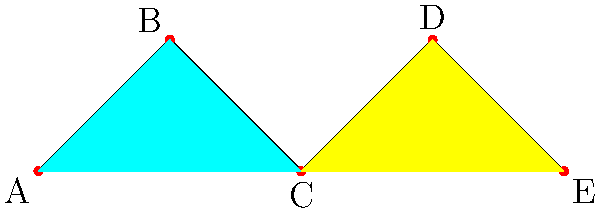Santander International is planning to optimize its ATM distribution in a city. The city can be represented as a graph where vertices are neighborhoods and edges indicate adjacent neighborhoods. ATMs in adjacent neighborhoods should have different maintenance schedules to ensure continuous service. Given the graph above, what is the minimum number of different maintenance schedules (colors) needed to ensure no adjacent neighborhoods have ATMs serviced at the same time? To solve this graph coloring problem, we'll follow these steps:

1. Analyze the graph structure:
   The graph has 5 vertices (A, B, C, D, E) representing neighborhoods.
   
2. Identify adjacent vertices:
   A is adjacent to B and C
   B is adjacent to A and C
   C is adjacent to A, B, D, and E
   D is adjacent to C and E
   E is adjacent to C and D

3. Apply the graph coloring algorithm:
   Start with vertex C as it has the highest degree (4 connections).
   Assign color 1 to C.
   
   For adjacent vertices to C:
   A and B can share a color (color 2) as they are not adjacent to each other.
   D and E can share a color (color 3) as they are not adjacent to A or B.

4. Verify the coloring:
   C: color 1
   A and B: color 2
   D and E: color 3

   No adjacent vertices share the same color.

5. Count the number of colors used: 3

Therefore, the minimum number of different maintenance schedules needed is 3.
Answer: 3 